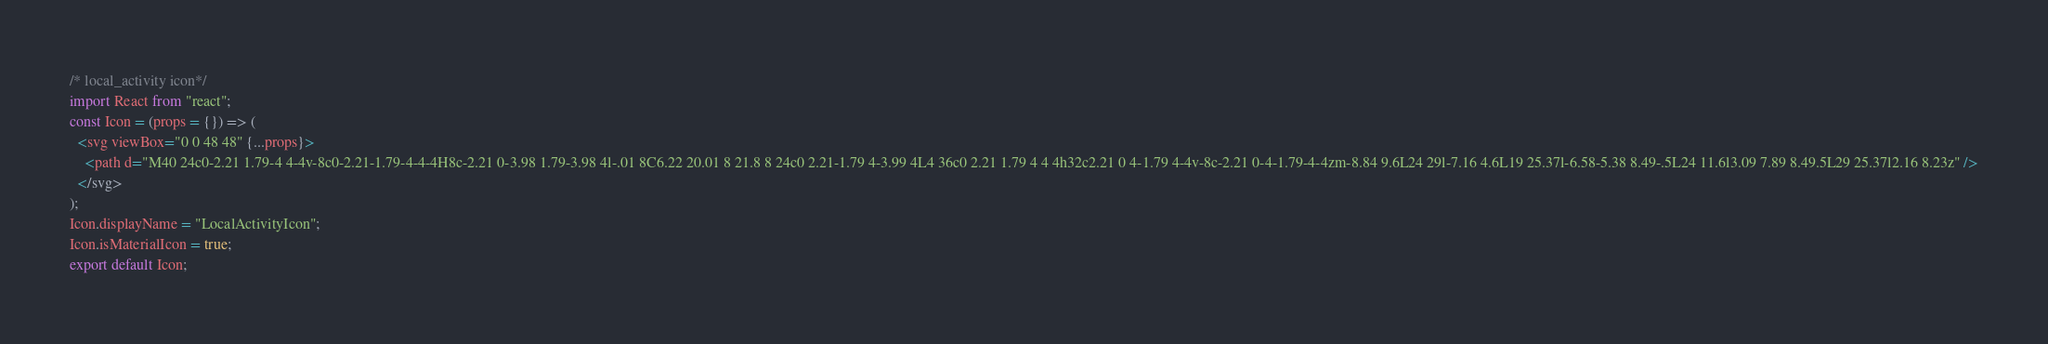Convert code to text. <code><loc_0><loc_0><loc_500><loc_500><_JavaScript_>/* local_activity icon*/
import React from "react";
const Icon = (props = {}) => (
  <svg viewBox="0 0 48 48" {...props}>
    <path d="M40 24c0-2.21 1.79-4 4-4v-8c0-2.21-1.79-4-4-4H8c-2.21 0-3.98 1.79-3.98 4l-.01 8C6.22 20.01 8 21.8 8 24c0 2.21-1.79 4-3.99 4L4 36c0 2.21 1.79 4 4 4h32c2.21 0 4-1.79 4-4v-8c-2.21 0-4-1.79-4-4zm-8.84 9.6L24 29l-7.16 4.6L19 25.37l-6.58-5.38 8.49-.5L24 11.6l3.09 7.89 8.49.5L29 25.37l2.16 8.23z" />
  </svg>
);
Icon.displayName = "LocalActivityIcon";
Icon.isMaterialIcon = true;
export default Icon;
</code> 